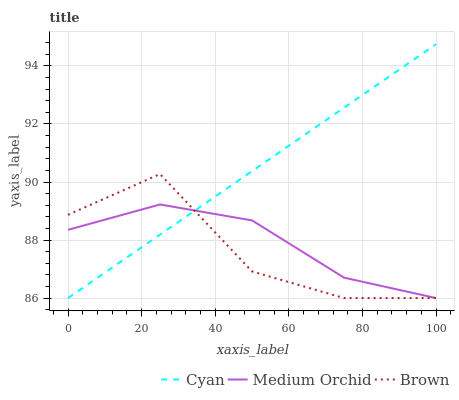Does Brown have the minimum area under the curve?
Answer yes or no. Yes. Does Cyan have the maximum area under the curve?
Answer yes or no. Yes. Does Medium Orchid have the minimum area under the curve?
Answer yes or no. No. Does Medium Orchid have the maximum area under the curve?
Answer yes or no. No. Is Cyan the smoothest?
Answer yes or no. Yes. Is Brown the roughest?
Answer yes or no. Yes. Is Medium Orchid the smoothest?
Answer yes or no. No. Is Medium Orchid the roughest?
Answer yes or no. No. Does Cyan have the lowest value?
Answer yes or no. Yes. Does Cyan have the highest value?
Answer yes or no. Yes. Does Brown have the highest value?
Answer yes or no. No. Does Cyan intersect Medium Orchid?
Answer yes or no. Yes. Is Cyan less than Medium Orchid?
Answer yes or no. No. Is Cyan greater than Medium Orchid?
Answer yes or no. No. 